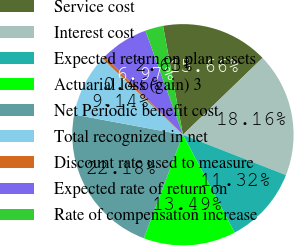Convert chart. <chart><loc_0><loc_0><loc_500><loc_500><pie_chart><fcel>Service cost<fcel>Interest cost<fcel>Expected return on plan assets<fcel>Actuarial loss (gain) 3<fcel>Net Periodic benefit cost<fcel>Total recognized in net<fcel>Discount rate used to measure<fcel>Expected rate of return on<fcel>Rate of compensation increase<nl><fcel>15.66%<fcel>18.16%<fcel>11.32%<fcel>13.49%<fcel>22.18%<fcel>9.14%<fcel>0.46%<fcel>6.97%<fcel>2.63%<nl></chart> 